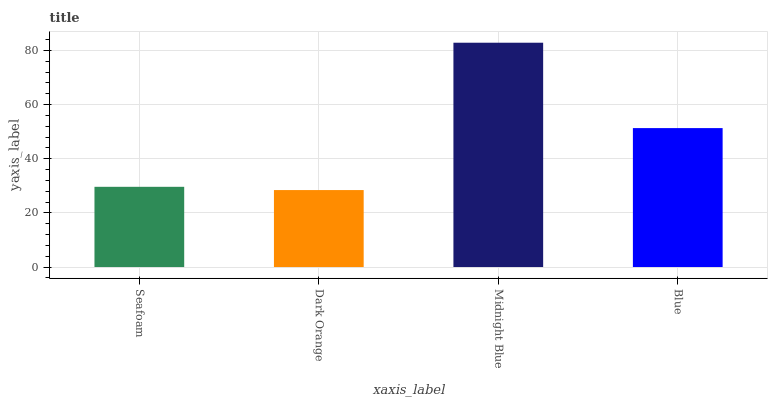Is Dark Orange the minimum?
Answer yes or no. Yes. Is Midnight Blue the maximum?
Answer yes or no. Yes. Is Midnight Blue the minimum?
Answer yes or no. No. Is Dark Orange the maximum?
Answer yes or no. No. Is Midnight Blue greater than Dark Orange?
Answer yes or no. Yes. Is Dark Orange less than Midnight Blue?
Answer yes or no. Yes. Is Dark Orange greater than Midnight Blue?
Answer yes or no. No. Is Midnight Blue less than Dark Orange?
Answer yes or no. No. Is Blue the high median?
Answer yes or no. Yes. Is Seafoam the low median?
Answer yes or no. Yes. Is Dark Orange the high median?
Answer yes or no. No. Is Blue the low median?
Answer yes or no. No. 